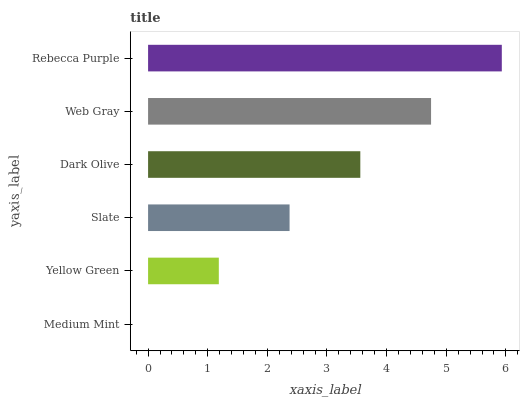Is Medium Mint the minimum?
Answer yes or no. Yes. Is Rebecca Purple the maximum?
Answer yes or no. Yes. Is Yellow Green the minimum?
Answer yes or no. No. Is Yellow Green the maximum?
Answer yes or no. No. Is Yellow Green greater than Medium Mint?
Answer yes or no. Yes. Is Medium Mint less than Yellow Green?
Answer yes or no. Yes. Is Medium Mint greater than Yellow Green?
Answer yes or no. No. Is Yellow Green less than Medium Mint?
Answer yes or no. No. Is Dark Olive the high median?
Answer yes or no. Yes. Is Slate the low median?
Answer yes or no. Yes. Is Yellow Green the high median?
Answer yes or no. No. Is Medium Mint the low median?
Answer yes or no. No. 